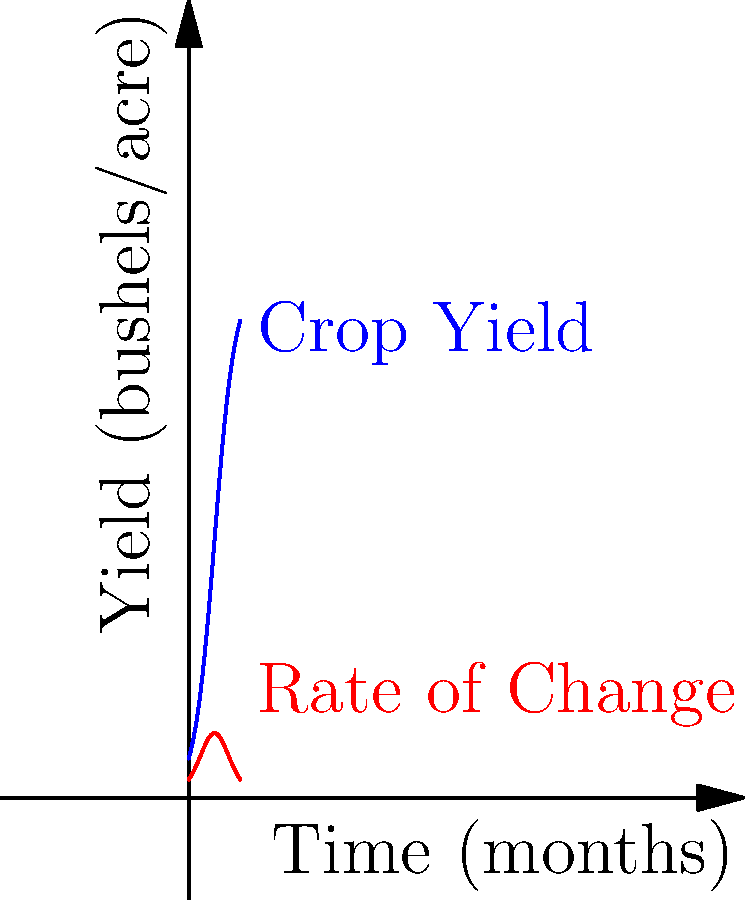A small-scale farmer is monitoring the yield of a new organic crop variety over time. The blue curve represents the crop yield in bushels per acre, and the red curve shows the rate of change of the yield. At what point in time (in months) is the rate of change of the crop yield at its maximum? To find the maximum rate of change, we need to analyze the red curve, which represents the derivative of the yield function.

1) The maximum point on the red curve corresponds to the time when the rate of change is highest.

2) From the graph, we can see that the red curve reaches its peak around the 5-month mark.

3) This point also corresponds to the inflection point of the blue curve (yield function), where the curve changes from concave up to concave down.

4) The inflection point occurs at the middle of the logistic growth curve, which in this case is at $x = 5$ months.

5) We can verify this mathematically. The given logistic function for yield is:

   $f(x) = \frac{100}{1 + e^{-0.5(x-5)}}$

   Its derivative (rate of change) is:

   $f'(x) = \frac{50e^{-0.5(x-5)}}{(1 + e^{-0.5(x-5)})^2}$

6) The maximum of $f'(x)$ occurs when $x = 5$, which can be proven by setting the second derivative to zero.

Therefore, the rate of change of the crop yield is at its maximum when $x = 5$ months.
Answer: 5 months 